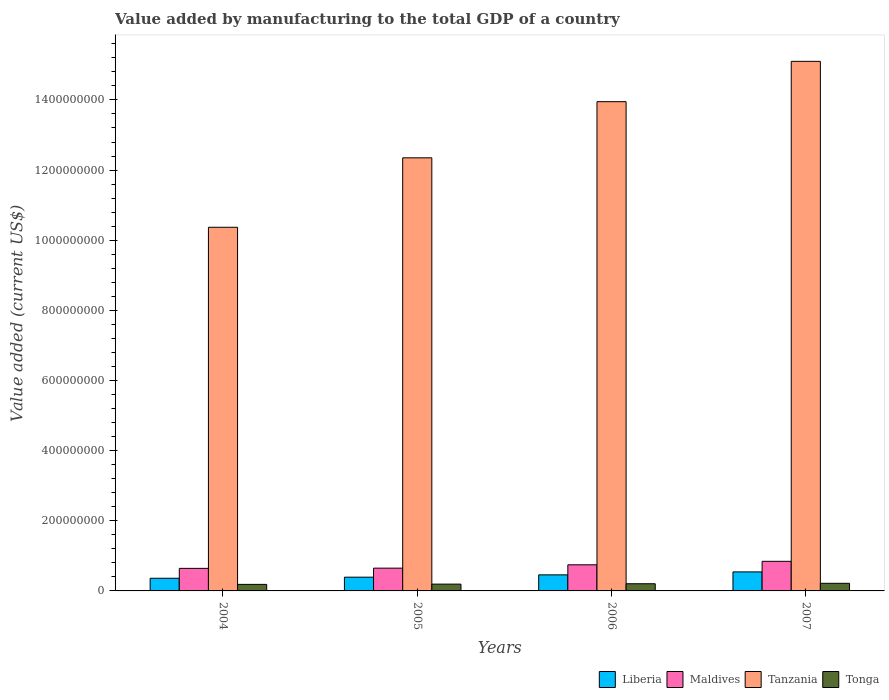How many groups of bars are there?
Your answer should be very brief. 4. Are the number of bars on each tick of the X-axis equal?
Provide a short and direct response. Yes. What is the label of the 1st group of bars from the left?
Make the answer very short. 2004. What is the value added by manufacturing to the total GDP in Tonga in 2007?
Your answer should be very brief. 2.17e+07. Across all years, what is the maximum value added by manufacturing to the total GDP in Tonga?
Your answer should be compact. 2.17e+07. Across all years, what is the minimum value added by manufacturing to the total GDP in Maldives?
Keep it short and to the point. 6.43e+07. In which year was the value added by manufacturing to the total GDP in Liberia minimum?
Your answer should be very brief. 2004. What is the total value added by manufacturing to the total GDP in Tonga in the graph?
Provide a succinct answer. 8.02e+07. What is the difference between the value added by manufacturing to the total GDP in Tanzania in 2004 and that in 2006?
Make the answer very short. -3.58e+08. What is the difference between the value added by manufacturing to the total GDP in Tonga in 2007 and the value added by manufacturing to the total GDP in Maldives in 2005?
Ensure brevity in your answer.  -4.32e+07. What is the average value added by manufacturing to the total GDP in Tonga per year?
Give a very brief answer. 2.01e+07. In the year 2007, what is the difference between the value added by manufacturing to the total GDP in Tanzania and value added by manufacturing to the total GDP in Liberia?
Provide a succinct answer. 1.46e+09. In how many years, is the value added by manufacturing to the total GDP in Tanzania greater than 840000000 US$?
Your answer should be very brief. 4. What is the ratio of the value added by manufacturing to the total GDP in Maldives in 2005 to that in 2006?
Keep it short and to the point. 0.87. Is the value added by manufacturing to the total GDP in Liberia in 2006 less than that in 2007?
Offer a terse response. Yes. What is the difference between the highest and the second highest value added by manufacturing to the total GDP in Liberia?
Ensure brevity in your answer.  8.43e+06. What is the difference between the highest and the lowest value added by manufacturing to the total GDP in Maldives?
Provide a short and direct response. 2.01e+07. In how many years, is the value added by manufacturing to the total GDP in Tonga greater than the average value added by manufacturing to the total GDP in Tonga taken over all years?
Your answer should be very brief. 2. Is it the case that in every year, the sum of the value added by manufacturing to the total GDP in Maldives and value added by manufacturing to the total GDP in Liberia is greater than the sum of value added by manufacturing to the total GDP in Tonga and value added by manufacturing to the total GDP in Tanzania?
Provide a succinct answer. Yes. What does the 2nd bar from the left in 2004 represents?
Keep it short and to the point. Maldives. What does the 2nd bar from the right in 2006 represents?
Give a very brief answer. Tanzania. How many bars are there?
Offer a terse response. 16. Are all the bars in the graph horizontal?
Provide a short and direct response. No. What is the difference between two consecutive major ticks on the Y-axis?
Offer a very short reply. 2.00e+08. Does the graph contain grids?
Keep it short and to the point. No. Where does the legend appear in the graph?
Offer a very short reply. Bottom right. How many legend labels are there?
Keep it short and to the point. 4. How are the legend labels stacked?
Provide a short and direct response. Horizontal. What is the title of the graph?
Your answer should be very brief. Value added by manufacturing to the total GDP of a country. What is the label or title of the X-axis?
Offer a terse response. Years. What is the label or title of the Y-axis?
Ensure brevity in your answer.  Value added (current US$). What is the Value added (current US$) of Liberia in 2004?
Make the answer very short. 3.61e+07. What is the Value added (current US$) in Maldives in 2004?
Provide a short and direct response. 6.43e+07. What is the Value added (current US$) in Tanzania in 2004?
Offer a very short reply. 1.04e+09. What is the Value added (current US$) of Tonga in 2004?
Keep it short and to the point. 1.86e+07. What is the Value added (current US$) in Liberia in 2005?
Offer a terse response. 3.92e+07. What is the Value added (current US$) in Maldives in 2005?
Offer a very short reply. 6.50e+07. What is the Value added (current US$) in Tanzania in 2005?
Give a very brief answer. 1.23e+09. What is the Value added (current US$) of Tonga in 2005?
Your answer should be very brief. 1.94e+07. What is the Value added (current US$) in Liberia in 2006?
Provide a succinct answer. 4.58e+07. What is the Value added (current US$) of Maldives in 2006?
Offer a very short reply. 7.45e+07. What is the Value added (current US$) in Tanzania in 2006?
Offer a very short reply. 1.40e+09. What is the Value added (current US$) in Tonga in 2006?
Ensure brevity in your answer.  2.05e+07. What is the Value added (current US$) of Liberia in 2007?
Provide a short and direct response. 5.42e+07. What is the Value added (current US$) of Maldives in 2007?
Your response must be concise. 8.44e+07. What is the Value added (current US$) of Tanzania in 2007?
Provide a succinct answer. 1.51e+09. What is the Value added (current US$) of Tonga in 2007?
Give a very brief answer. 2.17e+07. Across all years, what is the maximum Value added (current US$) in Liberia?
Offer a very short reply. 5.42e+07. Across all years, what is the maximum Value added (current US$) in Maldives?
Keep it short and to the point. 8.44e+07. Across all years, what is the maximum Value added (current US$) in Tanzania?
Offer a terse response. 1.51e+09. Across all years, what is the maximum Value added (current US$) of Tonga?
Ensure brevity in your answer.  2.17e+07. Across all years, what is the minimum Value added (current US$) of Liberia?
Your response must be concise. 3.61e+07. Across all years, what is the minimum Value added (current US$) of Maldives?
Your answer should be compact. 6.43e+07. Across all years, what is the minimum Value added (current US$) of Tanzania?
Offer a terse response. 1.04e+09. Across all years, what is the minimum Value added (current US$) of Tonga?
Give a very brief answer. 1.86e+07. What is the total Value added (current US$) of Liberia in the graph?
Your answer should be very brief. 1.75e+08. What is the total Value added (current US$) of Maldives in the graph?
Offer a terse response. 2.88e+08. What is the total Value added (current US$) of Tanzania in the graph?
Your answer should be compact. 5.18e+09. What is the total Value added (current US$) in Tonga in the graph?
Your answer should be very brief. 8.02e+07. What is the difference between the Value added (current US$) in Liberia in 2004 and that in 2005?
Provide a succinct answer. -3.07e+06. What is the difference between the Value added (current US$) of Maldives in 2004 and that in 2005?
Provide a short and direct response. -6.51e+05. What is the difference between the Value added (current US$) in Tanzania in 2004 and that in 2005?
Your answer should be compact. -1.98e+08. What is the difference between the Value added (current US$) in Tonga in 2004 and that in 2005?
Provide a succinct answer. -7.68e+05. What is the difference between the Value added (current US$) of Liberia in 2004 and that in 2006?
Ensure brevity in your answer.  -9.71e+06. What is the difference between the Value added (current US$) in Maldives in 2004 and that in 2006?
Keep it short and to the point. -1.02e+07. What is the difference between the Value added (current US$) of Tanzania in 2004 and that in 2006?
Provide a succinct answer. -3.58e+08. What is the difference between the Value added (current US$) in Tonga in 2004 and that in 2006?
Your answer should be very brief. -1.81e+06. What is the difference between the Value added (current US$) of Liberia in 2004 and that in 2007?
Your response must be concise. -1.81e+07. What is the difference between the Value added (current US$) of Maldives in 2004 and that in 2007?
Give a very brief answer. -2.01e+07. What is the difference between the Value added (current US$) of Tanzania in 2004 and that in 2007?
Your answer should be compact. -4.73e+08. What is the difference between the Value added (current US$) of Tonga in 2004 and that in 2007?
Your response must be concise. -3.09e+06. What is the difference between the Value added (current US$) of Liberia in 2005 and that in 2006?
Offer a terse response. -6.64e+06. What is the difference between the Value added (current US$) in Maldives in 2005 and that in 2006?
Keep it short and to the point. -9.51e+06. What is the difference between the Value added (current US$) in Tanzania in 2005 and that in 2006?
Make the answer very short. -1.60e+08. What is the difference between the Value added (current US$) in Tonga in 2005 and that in 2006?
Give a very brief answer. -1.04e+06. What is the difference between the Value added (current US$) in Liberia in 2005 and that in 2007?
Give a very brief answer. -1.51e+07. What is the difference between the Value added (current US$) in Maldives in 2005 and that in 2007?
Offer a terse response. -1.95e+07. What is the difference between the Value added (current US$) of Tanzania in 2005 and that in 2007?
Offer a very short reply. -2.75e+08. What is the difference between the Value added (current US$) in Tonga in 2005 and that in 2007?
Ensure brevity in your answer.  -2.32e+06. What is the difference between the Value added (current US$) of Liberia in 2006 and that in 2007?
Make the answer very short. -8.43e+06. What is the difference between the Value added (current US$) in Maldives in 2006 and that in 2007?
Make the answer very short. -9.94e+06. What is the difference between the Value added (current US$) of Tanzania in 2006 and that in 2007?
Make the answer very short. -1.15e+08. What is the difference between the Value added (current US$) in Tonga in 2006 and that in 2007?
Provide a succinct answer. -1.28e+06. What is the difference between the Value added (current US$) of Liberia in 2004 and the Value added (current US$) of Maldives in 2005?
Offer a terse response. -2.89e+07. What is the difference between the Value added (current US$) of Liberia in 2004 and the Value added (current US$) of Tanzania in 2005?
Offer a terse response. -1.20e+09. What is the difference between the Value added (current US$) in Liberia in 2004 and the Value added (current US$) in Tonga in 2005?
Provide a succinct answer. 1.67e+07. What is the difference between the Value added (current US$) of Maldives in 2004 and the Value added (current US$) of Tanzania in 2005?
Make the answer very short. -1.17e+09. What is the difference between the Value added (current US$) of Maldives in 2004 and the Value added (current US$) of Tonga in 2005?
Your response must be concise. 4.49e+07. What is the difference between the Value added (current US$) in Tanzania in 2004 and the Value added (current US$) in Tonga in 2005?
Ensure brevity in your answer.  1.02e+09. What is the difference between the Value added (current US$) of Liberia in 2004 and the Value added (current US$) of Maldives in 2006?
Ensure brevity in your answer.  -3.84e+07. What is the difference between the Value added (current US$) of Liberia in 2004 and the Value added (current US$) of Tanzania in 2006?
Offer a terse response. -1.36e+09. What is the difference between the Value added (current US$) in Liberia in 2004 and the Value added (current US$) in Tonga in 2006?
Give a very brief answer. 1.56e+07. What is the difference between the Value added (current US$) in Maldives in 2004 and the Value added (current US$) in Tanzania in 2006?
Keep it short and to the point. -1.33e+09. What is the difference between the Value added (current US$) of Maldives in 2004 and the Value added (current US$) of Tonga in 2006?
Your answer should be compact. 4.38e+07. What is the difference between the Value added (current US$) of Tanzania in 2004 and the Value added (current US$) of Tonga in 2006?
Provide a short and direct response. 1.02e+09. What is the difference between the Value added (current US$) in Liberia in 2004 and the Value added (current US$) in Maldives in 2007?
Ensure brevity in your answer.  -4.83e+07. What is the difference between the Value added (current US$) in Liberia in 2004 and the Value added (current US$) in Tanzania in 2007?
Your response must be concise. -1.47e+09. What is the difference between the Value added (current US$) in Liberia in 2004 and the Value added (current US$) in Tonga in 2007?
Offer a terse response. 1.44e+07. What is the difference between the Value added (current US$) of Maldives in 2004 and the Value added (current US$) of Tanzania in 2007?
Offer a terse response. -1.45e+09. What is the difference between the Value added (current US$) of Maldives in 2004 and the Value added (current US$) of Tonga in 2007?
Provide a short and direct response. 4.26e+07. What is the difference between the Value added (current US$) of Tanzania in 2004 and the Value added (current US$) of Tonga in 2007?
Your answer should be very brief. 1.02e+09. What is the difference between the Value added (current US$) in Liberia in 2005 and the Value added (current US$) in Maldives in 2006?
Provide a short and direct response. -3.53e+07. What is the difference between the Value added (current US$) in Liberia in 2005 and the Value added (current US$) in Tanzania in 2006?
Your answer should be very brief. -1.36e+09. What is the difference between the Value added (current US$) in Liberia in 2005 and the Value added (current US$) in Tonga in 2006?
Offer a very short reply. 1.87e+07. What is the difference between the Value added (current US$) in Maldives in 2005 and the Value added (current US$) in Tanzania in 2006?
Keep it short and to the point. -1.33e+09. What is the difference between the Value added (current US$) of Maldives in 2005 and the Value added (current US$) of Tonga in 2006?
Provide a short and direct response. 4.45e+07. What is the difference between the Value added (current US$) in Tanzania in 2005 and the Value added (current US$) in Tonga in 2006?
Offer a very short reply. 1.21e+09. What is the difference between the Value added (current US$) of Liberia in 2005 and the Value added (current US$) of Maldives in 2007?
Give a very brief answer. -4.52e+07. What is the difference between the Value added (current US$) of Liberia in 2005 and the Value added (current US$) of Tanzania in 2007?
Your answer should be very brief. -1.47e+09. What is the difference between the Value added (current US$) in Liberia in 2005 and the Value added (current US$) in Tonga in 2007?
Your response must be concise. 1.74e+07. What is the difference between the Value added (current US$) of Maldives in 2005 and the Value added (current US$) of Tanzania in 2007?
Provide a short and direct response. -1.45e+09. What is the difference between the Value added (current US$) of Maldives in 2005 and the Value added (current US$) of Tonga in 2007?
Your response must be concise. 4.32e+07. What is the difference between the Value added (current US$) in Tanzania in 2005 and the Value added (current US$) in Tonga in 2007?
Keep it short and to the point. 1.21e+09. What is the difference between the Value added (current US$) of Liberia in 2006 and the Value added (current US$) of Maldives in 2007?
Offer a terse response. -3.86e+07. What is the difference between the Value added (current US$) of Liberia in 2006 and the Value added (current US$) of Tanzania in 2007?
Offer a terse response. -1.46e+09. What is the difference between the Value added (current US$) in Liberia in 2006 and the Value added (current US$) in Tonga in 2007?
Provide a succinct answer. 2.41e+07. What is the difference between the Value added (current US$) in Maldives in 2006 and the Value added (current US$) in Tanzania in 2007?
Ensure brevity in your answer.  -1.44e+09. What is the difference between the Value added (current US$) of Maldives in 2006 and the Value added (current US$) of Tonga in 2007?
Provide a short and direct response. 5.27e+07. What is the difference between the Value added (current US$) of Tanzania in 2006 and the Value added (current US$) of Tonga in 2007?
Provide a succinct answer. 1.37e+09. What is the average Value added (current US$) in Liberia per year?
Offer a very short reply. 4.38e+07. What is the average Value added (current US$) of Maldives per year?
Your response must be concise. 7.20e+07. What is the average Value added (current US$) of Tanzania per year?
Keep it short and to the point. 1.29e+09. What is the average Value added (current US$) of Tonga per year?
Offer a very short reply. 2.01e+07. In the year 2004, what is the difference between the Value added (current US$) in Liberia and Value added (current US$) in Maldives?
Your answer should be compact. -2.82e+07. In the year 2004, what is the difference between the Value added (current US$) in Liberia and Value added (current US$) in Tanzania?
Give a very brief answer. -1.00e+09. In the year 2004, what is the difference between the Value added (current US$) in Liberia and Value added (current US$) in Tonga?
Offer a terse response. 1.75e+07. In the year 2004, what is the difference between the Value added (current US$) of Maldives and Value added (current US$) of Tanzania?
Offer a very short reply. -9.73e+08. In the year 2004, what is the difference between the Value added (current US$) of Maldives and Value added (current US$) of Tonga?
Offer a terse response. 4.57e+07. In the year 2004, what is the difference between the Value added (current US$) of Tanzania and Value added (current US$) of Tonga?
Give a very brief answer. 1.02e+09. In the year 2005, what is the difference between the Value added (current US$) of Liberia and Value added (current US$) of Maldives?
Keep it short and to the point. -2.58e+07. In the year 2005, what is the difference between the Value added (current US$) of Liberia and Value added (current US$) of Tanzania?
Provide a succinct answer. -1.20e+09. In the year 2005, what is the difference between the Value added (current US$) in Liberia and Value added (current US$) in Tonga?
Provide a succinct answer. 1.98e+07. In the year 2005, what is the difference between the Value added (current US$) of Maldives and Value added (current US$) of Tanzania?
Your answer should be very brief. -1.17e+09. In the year 2005, what is the difference between the Value added (current US$) in Maldives and Value added (current US$) in Tonga?
Your answer should be very brief. 4.55e+07. In the year 2005, what is the difference between the Value added (current US$) in Tanzania and Value added (current US$) in Tonga?
Offer a terse response. 1.22e+09. In the year 2006, what is the difference between the Value added (current US$) of Liberia and Value added (current US$) of Maldives?
Provide a succinct answer. -2.87e+07. In the year 2006, what is the difference between the Value added (current US$) of Liberia and Value added (current US$) of Tanzania?
Ensure brevity in your answer.  -1.35e+09. In the year 2006, what is the difference between the Value added (current US$) of Liberia and Value added (current US$) of Tonga?
Your answer should be compact. 2.54e+07. In the year 2006, what is the difference between the Value added (current US$) of Maldives and Value added (current US$) of Tanzania?
Your answer should be compact. -1.32e+09. In the year 2006, what is the difference between the Value added (current US$) of Maldives and Value added (current US$) of Tonga?
Provide a short and direct response. 5.40e+07. In the year 2006, what is the difference between the Value added (current US$) in Tanzania and Value added (current US$) in Tonga?
Your answer should be very brief. 1.37e+09. In the year 2007, what is the difference between the Value added (current US$) of Liberia and Value added (current US$) of Maldives?
Offer a terse response. -3.02e+07. In the year 2007, what is the difference between the Value added (current US$) of Liberia and Value added (current US$) of Tanzania?
Provide a succinct answer. -1.46e+09. In the year 2007, what is the difference between the Value added (current US$) of Liberia and Value added (current US$) of Tonga?
Your answer should be compact. 3.25e+07. In the year 2007, what is the difference between the Value added (current US$) in Maldives and Value added (current US$) in Tanzania?
Ensure brevity in your answer.  -1.43e+09. In the year 2007, what is the difference between the Value added (current US$) in Maldives and Value added (current US$) in Tonga?
Your answer should be compact. 6.27e+07. In the year 2007, what is the difference between the Value added (current US$) of Tanzania and Value added (current US$) of Tonga?
Ensure brevity in your answer.  1.49e+09. What is the ratio of the Value added (current US$) in Liberia in 2004 to that in 2005?
Your answer should be compact. 0.92. What is the ratio of the Value added (current US$) of Maldives in 2004 to that in 2005?
Give a very brief answer. 0.99. What is the ratio of the Value added (current US$) in Tanzania in 2004 to that in 2005?
Your answer should be very brief. 0.84. What is the ratio of the Value added (current US$) in Tonga in 2004 to that in 2005?
Offer a terse response. 0.96. What is the ratio of the Value added (current US$) in Liberia in 2004 to that in 2006?
Your answer should be very brief. 0.79. What is the ratio of the Value added (current US$) in Maldives in 2004 to that in 2006?
Ensure brevity in your answer.  0.86. What is the ratio of the Value added (current US$) of Tanzania in 2004 to that in 2006?
Make the answer very short. 0.74. What is the ratio of the Value added (current US$) in Tonga in 2004 to that in 2006?
Offer a very short reply. 0.91. What is the ratio of the Value added (current US$) in Liberia in 2004 to that in 2007?
Ensure brevity in your answer.  0.67. What is the ratio of the Value added (current US$) of Maldives in 2004 to that in 2007?
Provide a short and direct response. 0.76. What is the ratio of the Value added (current US$) in Tanzania in 2004 to that in 2007?
Provide a short and direct response. 0.69. What is the ratio of the Value added (current US$) in Tonga in 2004 to that in 2007?
Your answer should be very brief. 0.86. What is the ratio of the Value added (current US$) in Liberia in 2005 to that in 2006?
Provide a succinct answer. 0.86. What is the ratio of the Value added (current US$) in Maldives in 2005 to that in 2006?
Offer a very short reply. 0.87. What is the ratio of the Value added (current US$) in Tanzania in 2005 to that in 2006?
Keep it short and to the point. 0.89. What is the ratio of the Value added (current US$) in Tonga in 2005 to that in 2006?
Provide a succinct answer. 0.95. What is the ratio of the Value added (current US$) of Liberia in 2005 to that in 2007?
Make the answer very short. 0.72. What is the ratio of the Value added (current US$) of Maldives in 2005 to that in 2007?
Keep it short and to the point. 0.77. What is the ratio of the Value added (current US$) of Tanzania in 2005 to that in 2007?
Provide a succinct answer. 0.82. What is the ratio of the Value added (current US$) of Tonga in 2005 to that in 2007?
Your answer should be compact. 0.89. What is the ratio of the Value added (current US$) in Liberia in 2006 to that in 2007?
Offer a terse response. 0.84. What is the ratio of the Value added (current US$) in Maldives in 2006 to that in 2007?
Keep it short and to the point. 0.88. What is the ratio of the Value added (current US$) of Tanzania in 2006 to that in 2007?
Offer a terse response. 0.92. What is the ratio of the Value added (current US$) of Tonga in 2006 to that in 2007?
Offer a terse response. 0.94. What is the difference between the highest and the second highest Value added (current US$) of Liberia?
Give a very brief answer. 8.43e+06. What is the difference between the highest and the second highest Value added (current US$) of Maldives?
Provide a short and direct response. 9.94e+06. What is the difference between the highest and the second highest Value added (current US$) in Tanzania?
Provide a short and direct response. 1.15e+08. What is the difference between the highest and the second highest Value added (current US$) of Tonga?
Your answer should be compact. 1.28e+06. What is the difference between the highest and the lowest Value added (current US$) of Liberia?
Offer a very short reply. 1.81e+07. What is the difference between the highest and the lowest Value added (current US$) of Maldives?
Your answer should be very brief. 2.01e+07. What is the difference between the highest and the lowest Value added (current US$) of Tanzania?
Offer a terse response. 4.73e+08. What is the difference between the highest and the lowest Value added (current US$) in Tonga?
Ensure brevity in your answer.  3.09e+06. 